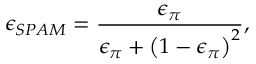<formula> <loc_0><loc_0><loc_500><loc_500>\epsilon _ { S P A M } = \frac { \epsilon _ { \pi } } { \epsilon _ { \pi } + \left ( 1 - \epsilon _ { \pi } \right ) ^ { 2 } } ,</formula> 